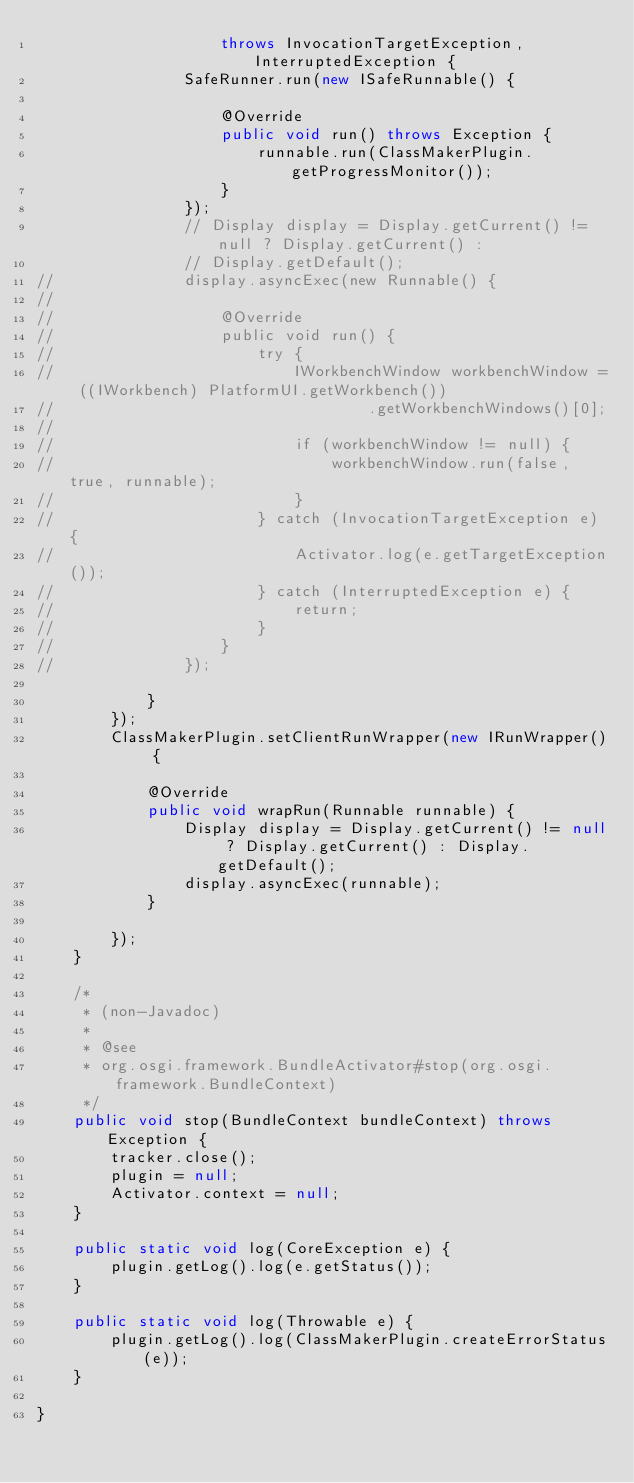<code> <loc_0><loc_0><loc_500><loc_500><_Java_>					throws InvocationTargetException, InterruptedException {
				SafeRunner.run(new ISafeRunnable() {

					@Override
					public void run() throws Exception {
						runnable.run(ClassMakerPlugin.getProgressMonitor());
					}
				});
				// Display display = Display.getCurrent() != null ? Display.getCurrent() :
				// Display.getDefault();
//				display.asyncExec(new Runnable() {
//		
//					@Override
//					public void run() {
//						try {
//							IWorkbenchWindow workbenchWindow = ((IWorkbench) PlatformUI.getWorkbench())
//									.getWorkbenchWindows()[0];
//		
//							if (workbenchWindow != null) {
//								workbenchWindow.run(false, true, runnable);
//							}
//						} catch (InvocationTargetException e) {
//							Activator.log(e.getTargetException());
//						} catch (InterruptedException e) {
//							return;
//						}
//					}
//				});

			}
		});
		ClassMakerPlugin.setClientRunWrapper(new IRunWrapper() {

			@Override
			public void wrapRun(Runnable runnable) {
				Display display = Display.getCurrent() != null ? Display.getCurrent() : Display.getDefault();
				display.asyncExec(runnable);
			}

		});
	}

	/*
	 * (non-Javadoc)
	 * 
	 * @see
	 * org.osgi.framework.BundleActivator#stop(org.osgi.framework.BundleContext)
	 */
	public void stop(BundleContext bundleContext) throws Exception {
		tracker.close();
		plugin = null;
		Activator.context = null;
	}

	public static void log(CoreException e) {
		plugin.getLog().log(e.getStatus());
	}

	public static void log(Throwable e) {
		plugin.getLog().log(ClassMakerPlugin.createErrorStatus(e));
	}

}
</code> 